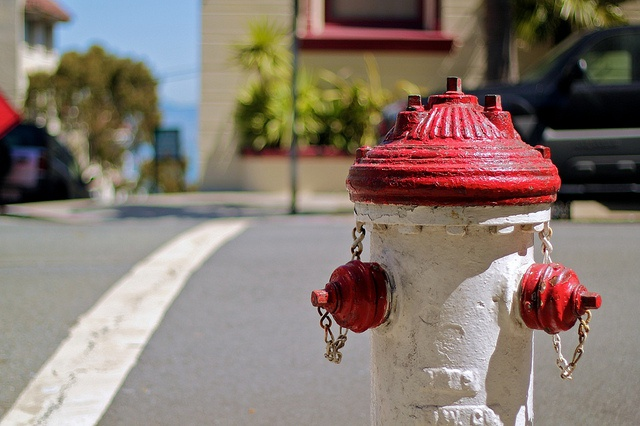Describe the objects in this image and their specific colors. I can see fire hydrant in gray, darkgray, and maroon tones, car in gray, black, and darkgreen tones, and car in gray, black, navy, and brown tones in this image. 